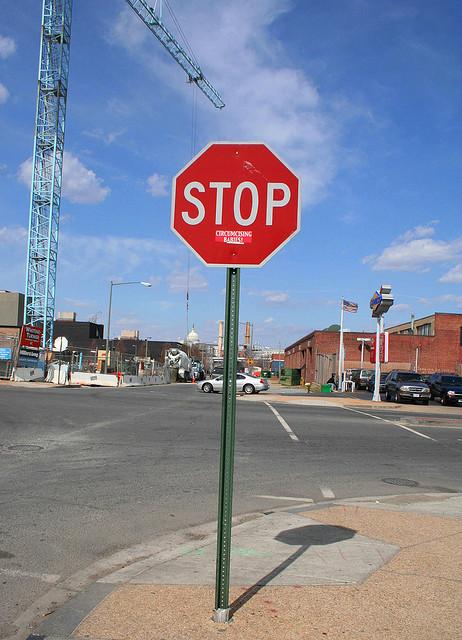Where is the crane?
Be succinct. Left. Is there a shadow on the sidewalk?
Quick response, please. Yes. What does this sign tell people to do?
Short answer required. Stop. 